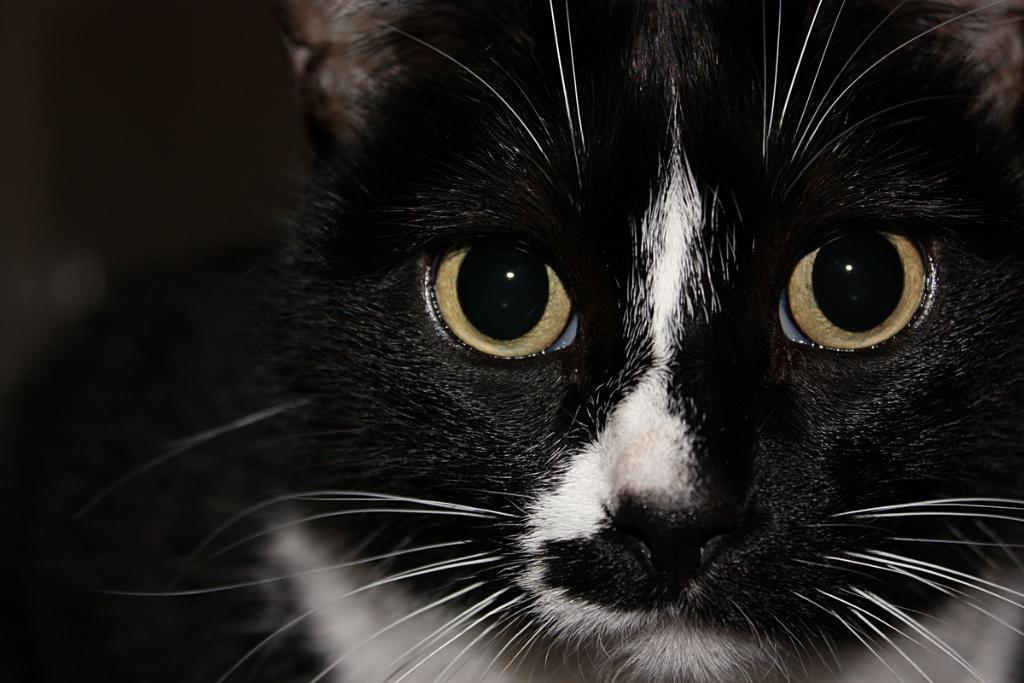Please provide a concise description of this image. In this image we can see a cat. There is a blur background in the image. 